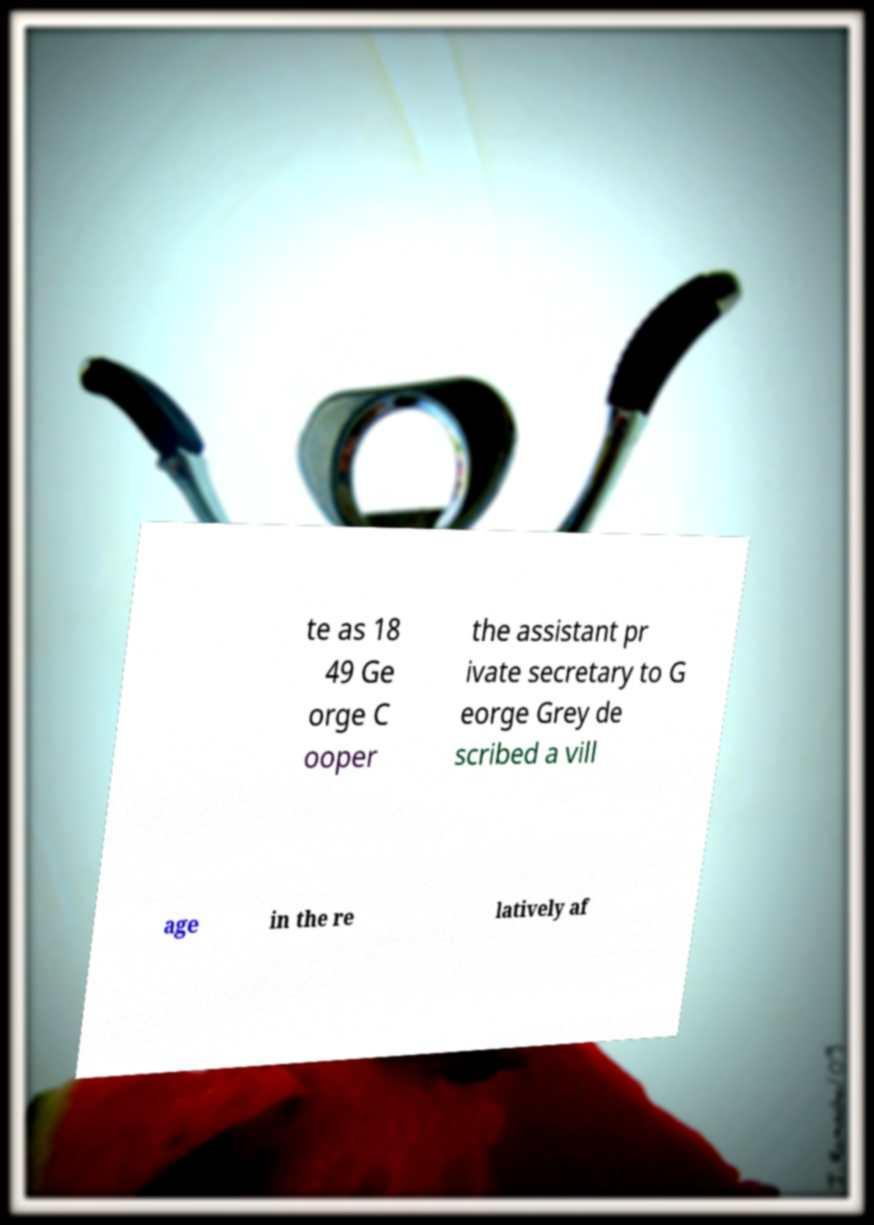Can you read and provide the text displayed in the image?This photo seems to have some interesting text. Can you extract and type it out for me? te as 18 49 Ge orge C ooper the assistant pr ivate secretary to G eorge Grey de scribed a vill age in the re latively af 